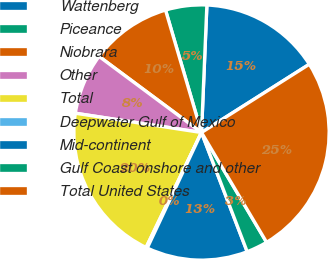Convert chart. <chart><loc_0><loc_0><loc_500><loc_500><pie_chart><fcel>Wattenberg<fcel>Piceance<fcel>Niobrara<fcel>Other<fcel>Total<fcel>Deepwater Gulf of Mexico<fcel>Mid-continent<fcel>Gulf Coast onshore and other<fcel>Total United States<nl><fcel>15.34%<fcel>5.22%<fcel>10.28%<fcel>7.75%<fcel>20.26%<fcel>0.16%<fcel>12.81%<fcel>2.69%<fcel>25.46%<nl></chart> 